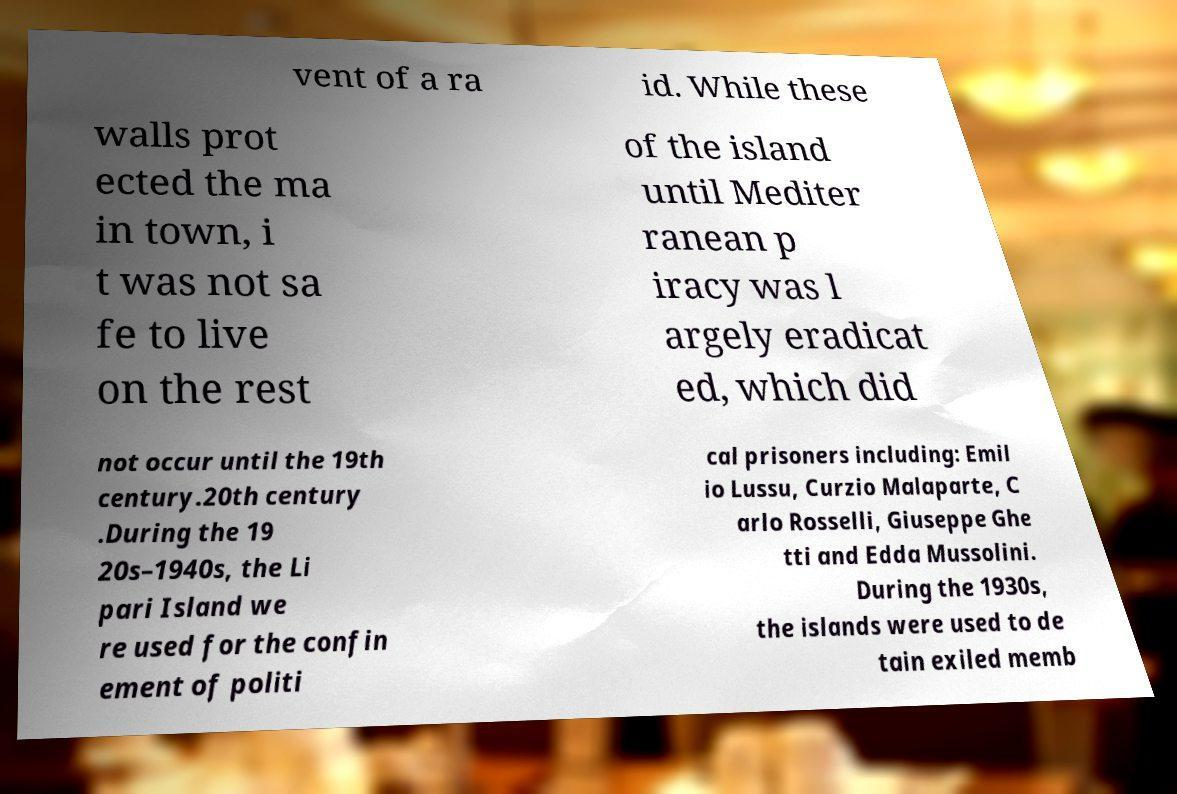Can you accurately transcribe the text from the provided image for me? vent of a ra id. While these walls prot ected the ma in town, i t was not sa fe to live on the rest of the island until Mediter ranean p iracy was l argely eradicat ed, which did not occur until the 19th century.20th century .During the 19 20s–1940s, the Li pari Island we re used for the confin ement of politi cal prisoners including: Emil io Lussu, Curzio Malaparte, C arlo Rosselli, Giuseppe Ghe tti and Edda Mussolini. During the 1930s, the islands were used to de tain exiled memb 